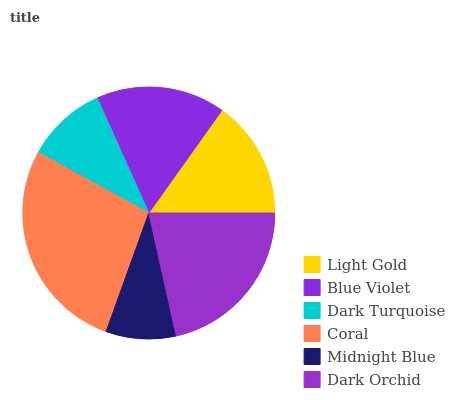Is Midnight Blue the minimum?
Answer yes or no. Yes. Is Coral the maximum?
Answer yes or no. Yes. Is Blue Violet the minimum?
Answer yes or no. No. Is Blue Violet the maximum?
Answer yes or no. No. Is Blue Violet greater than Light Gold?
Answer yes or no. Yes. Is Light Gold less than Blue Violet?
Answer yes or no. Yes. Is Light Gold greater than Blue Violet?
Answer yes or no. No. Is Blue Violet less than Light Gold?
Answer yes or no. No. Is Blue Violet the high median?
Answer yes or no. Yes. Is Light Gold the low median?
Answer yes or no. Yes. Is Midnight Blue the high median?
Answer yes or no. No. Is Dark Orchid the low median?
Answer yes or no. No. 